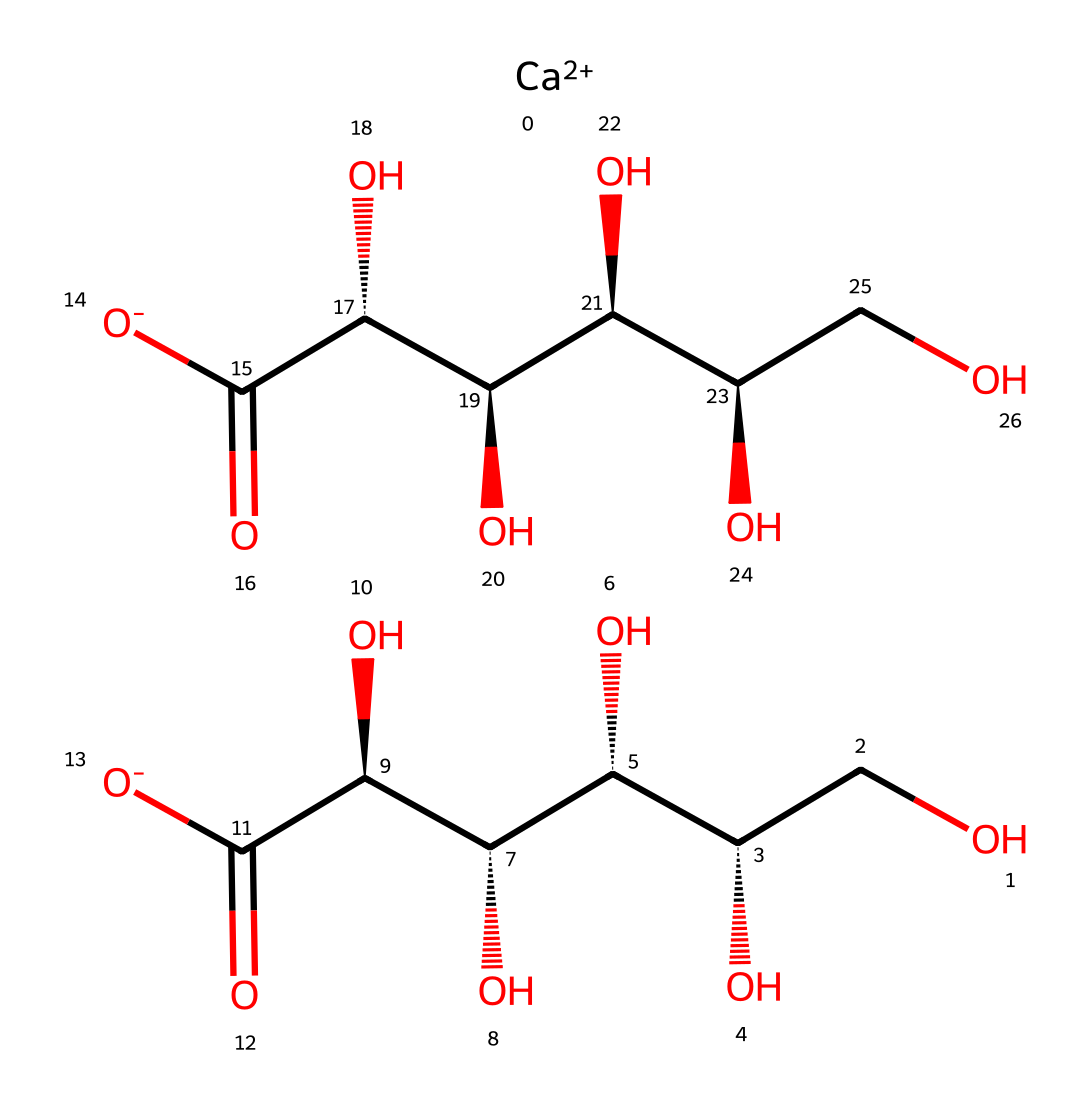What is the molecular formula of calcium gluconate? To determine the molecular formula, we analyze the SMILES representation, which includes various atoms including calcium (Ca), carbon (C), hydrogen (H), and oxygen (O). Calculating from the SMILES gives us C12H22CaO14.
Answer: C12H22CaO14 How many carbon atoms are present in calcium gluconate? In the SMILES notation, we count the number of 'C' symbols, which represent carbon atoms. There are 12 'C' symbols indicating that there are 12 carbon atoms in the structure.
Answer: 12 What type of compound is calcium gluconate? Calcium gluconate is classified as a calcium salt of gluconic acid based on its structure that includes calcium ions and gluconate anions.
Answer: calcium salt How many hydroxyl (OH) groups are present in calcium gluconate? By examining the SMILES, we note that each 'O' connected directly to a 'C' with an 'H' indicates a hydroxyl group. Counting these shows there are 10 hydroxyl groups.
Answer: 10 What is the role of calcium in calcium gluconate? The calcium in calcium gluconate serves as an electrolyte, essential for many physiological functions including muscle contractions and nerve transmission.
Answer: electrolyte Does calcium gluconate have a potential use in dietary supplementation? Yes, calcium gluconate is commonly used as a dietary supplement to support bone health and manage calcium levels, especially in aging individuals.
Answer: yes What makes calcium gluconate soluble in water? The presence of multiple hydroxyl groups in the molecule increases its polarity, allowing it to dissolve well in water.
Answer: polarity 